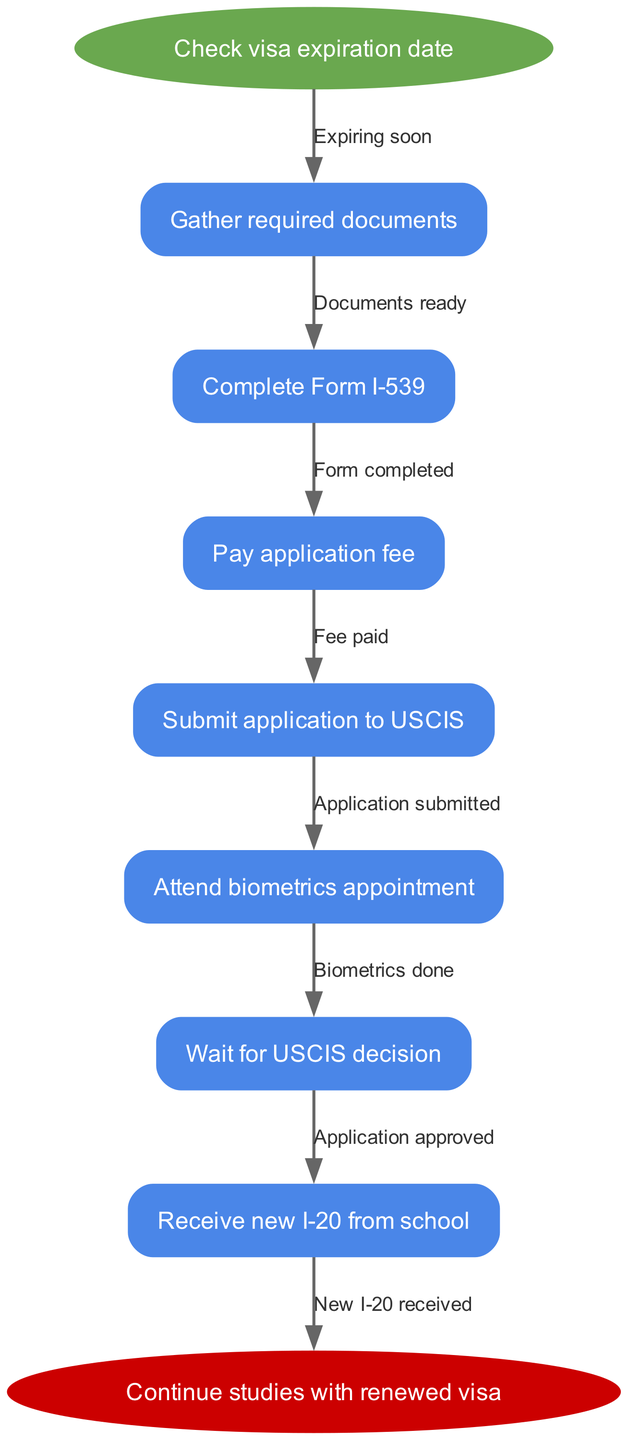What is the first step in the visa renewal process? The first node in the diagram indicates that the process begins with checking the visa expiration date. This is visually represented as the first action that must be completed before proceeding.
Answer: Check visa expiration date How many nodes are in the diagram? Counting all the nodes listed in the diagram, including the start and end nodes, gives a total of seven nodes. This can be confirmed by listing each step from start to end.
Answer: Seven What is the final step before receiving the new I-20? The last process node leading to the end node is submitting the application to USCIS, followed by attending the biometrics appointment and waiting for a decision. Thus, the last action before receiving the new I-20 is waiting for USCIS decision, which must occur after attending biometrics.
Answer: Wait for USCIS decision What must you do after gathering required documents? After the action of gathering required documents, the flow graph directs to the next step, which is completing Form I-539. This indicates a sequential relationship between these steps.
Answer: Complete Form I-539 If the application is approved, what is the next node? When the application is approved, according to the flow chart sequence, the next action is to receive the new I-20 from the school. This forms a direct connection in the flow of actions.
Answer: Receive new I-20 from school What do you need to do once the documents are ready? Upon the readiness of the necessary documents, the flow directs to the next step of completing Form I-539, indicating that this is a prerequisite action before any subsequent steps can occur.
Answer: Complete Form I-539 What is the purpose of paying the application fee? Paying the application fee is a required step that enables the submission of the visa renewal application. The fee acts as a necessary condition before moving on in the process.
Answer: Submit application to USCIS What step follows the biometrics appointment? After attending the biometrics appointment, the subsequent step outlined in the diagram is waiting for the USCIS decision, signifying a delay before progressing further.
Answer: Wait for USCIS decision 